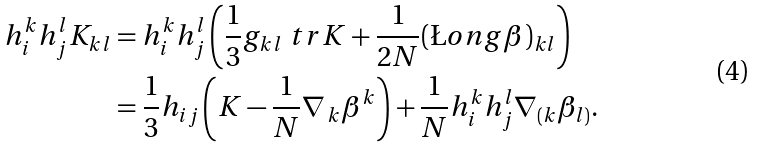Convert formula to latex. <formula><loc_0><loc_0><loc_500><loc_500>h _ { i } ^ { k } h _ { j } ^ { l } K _ { k l } & = h _ { i } ^ { k } h _ { j } ^ { l } \left ( \frac { 1 } { 3 } g _ { k l } \ t r K + \frac { 1 } { 2 N } ( \L o n g \beta ) _ { k l } \right ) \\ & = \frac { 1 } { 3 } h _ { i j } \left ( K - \frac { 1 } { N } \nabla _ { \, k } \beta ^ { k } \right ) + \frac { 1 } { N } h _ { i } ^ { k } h _ { j } ^ { l } \nabla _ { ( k } \beta _ { l ) } .</formula> 